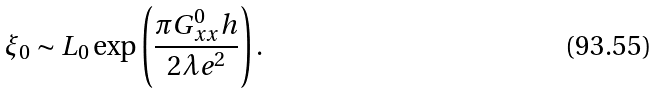<formula> <loc_0><loc_0><loc_500><loc_500>\xi _ { 0 } \sim L _ { 0 } \exp \left ( \frac { \pi G _ { x x } ^ { 0 } h } { 2 \lambda e ^ { 2 } } \right ) .</formula> 